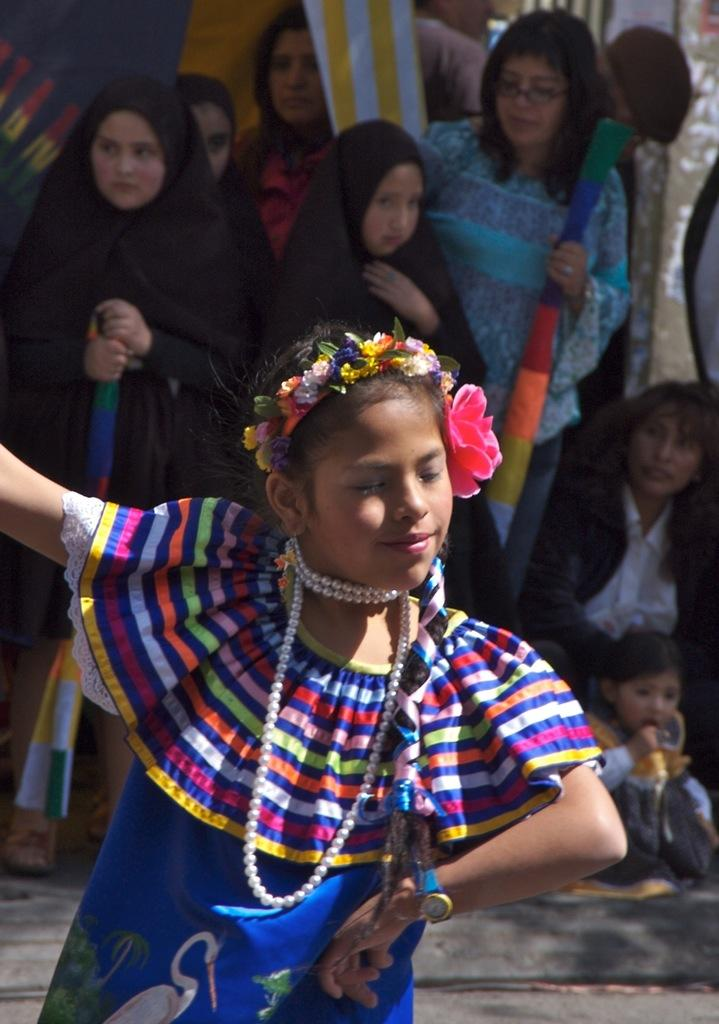What is the girl in the image doing? There is a girl dancing in the image. What can be seen in the background of the image? There are banners and people on a path in the background of the image. What are some people in the background holding? Some people in the background are holding objects. What type of match is being played in the image? There is no match being played in the image; it features a girl dancing and people in the background. Can you tell me how many bags of popcorn are visible in the image? There is no popcorn present in the image. 